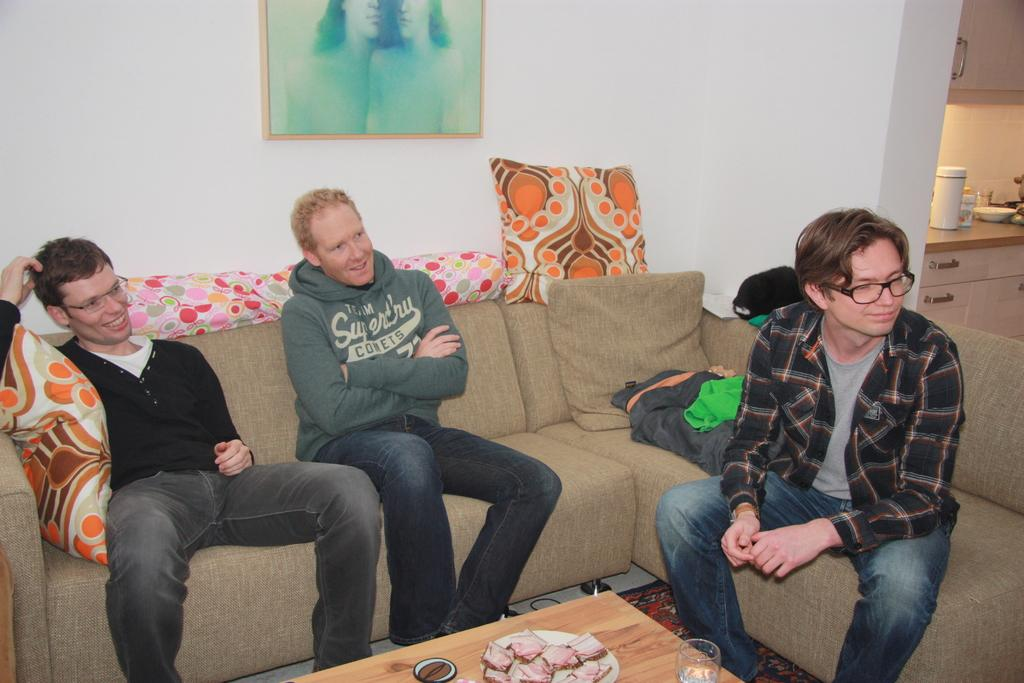How many people are in the image? There are three men in the image. What are the men doing in the image? The men are sitting on a sofa. Can you describe the sofa in the image? The sofa has cushions at the back. What is located behind the sofa? There is a table behind the sofa. What is on the table? There is food on a plate on the table. What can be seen on the wall behind the table? There is a painting with a frame hanging on the wall. How many geese are visible in the scene? There are no geese present in the image. What type of slip is the man wearing on his feet? There is no information about the men's footwear in the image. 